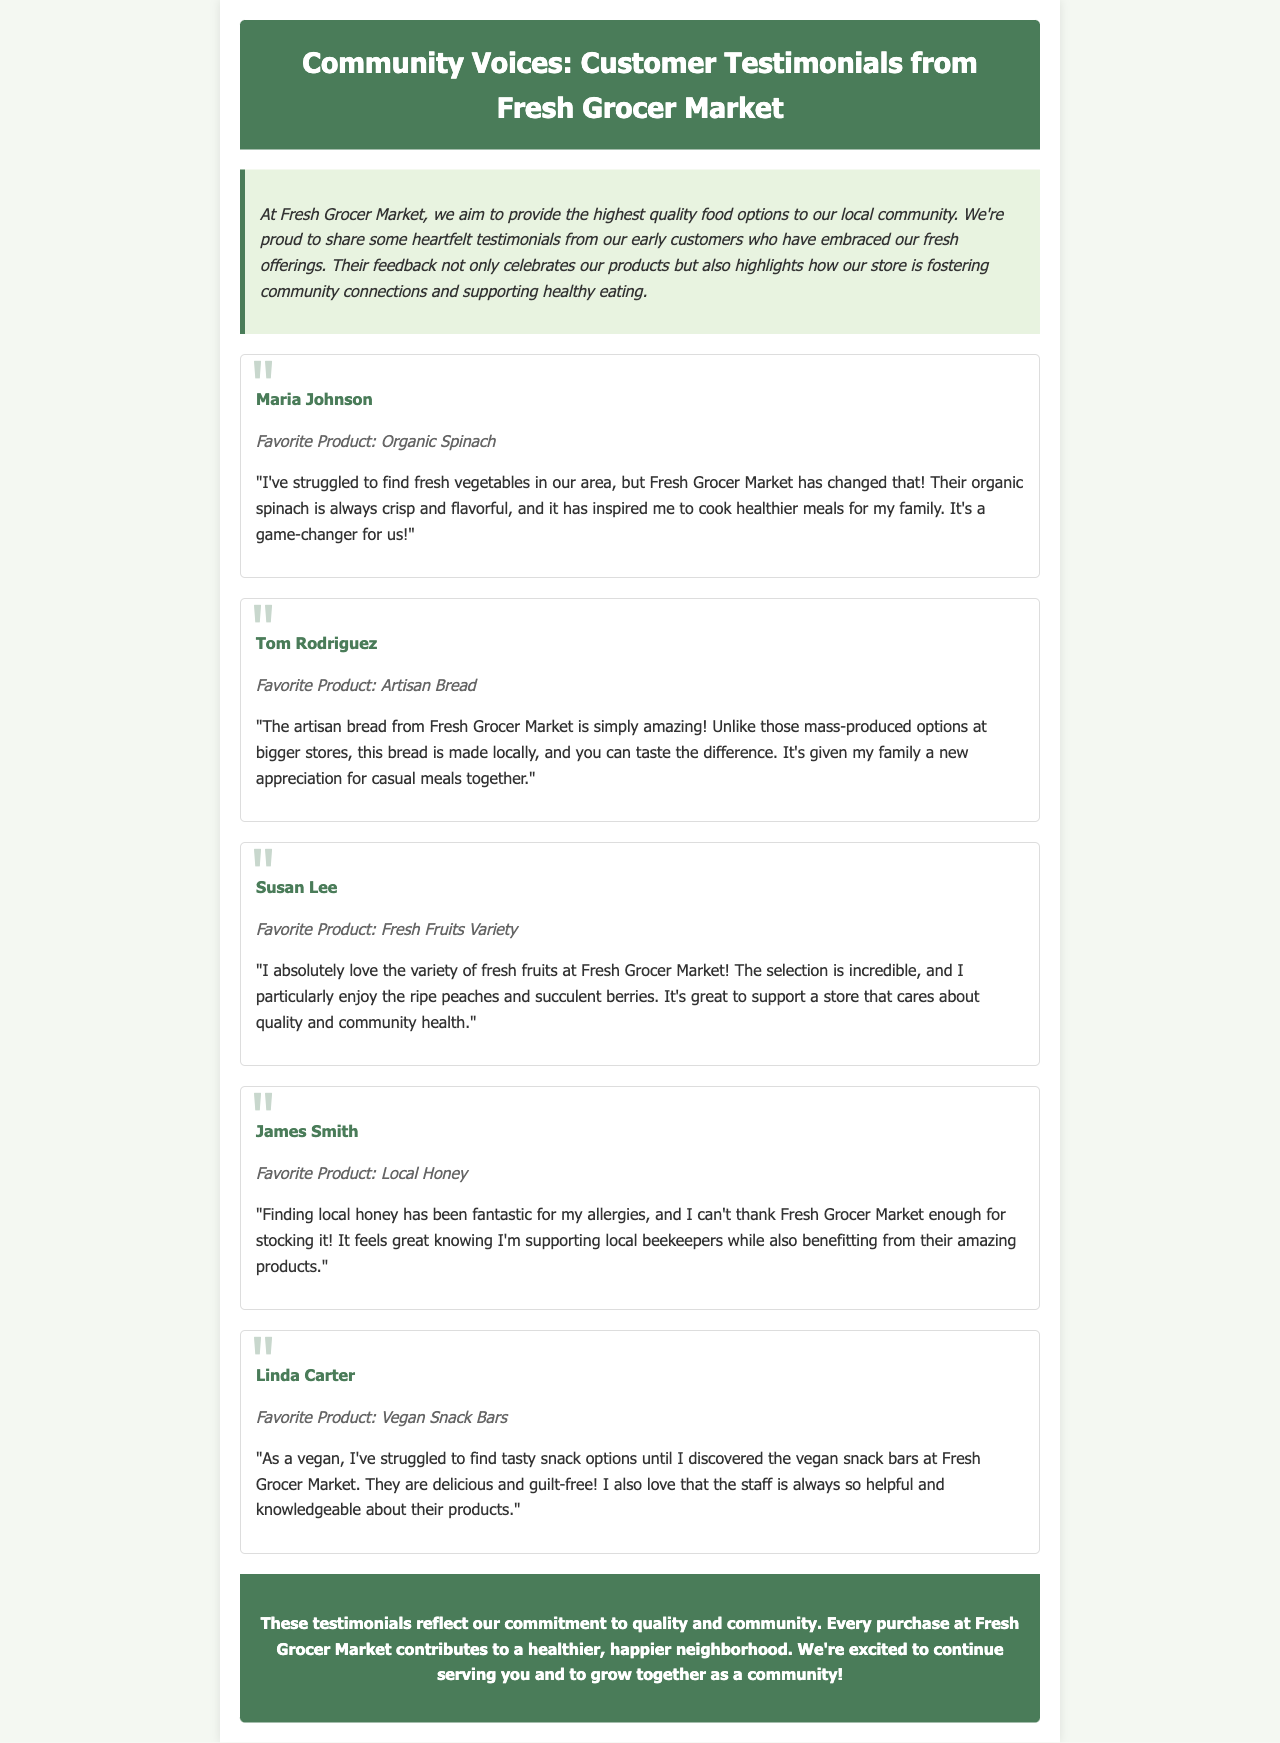What is the name of the first customer testimonial? The document presents a series of testimonials from various customers, starting with Maria Johnson.
Answer: Maria Johnson What is Maria Johnson's favorite product? According to the testimonial, Maria Johnson's favorite product is explicitly stated as organic spinach.
Answer: Organic Spinach How many testimonials are included in the newsletter? The newsletter features a total of five customer testimonials highlighting various products.
Answer: Five Which product did Tom Rodriguez appreciate most? Tom Rodriguez expresses his appreciation for artisan bread that he finds amazing compared to other options.
Answer: Artisan Bread What positive change did Fresh Grocer Market bring to Maria Johnson's cooking habits? Maria mentions that the availability of fresh vegetables has inspired her to cook healthier meals for her family.
Answer: Healthier meals What is the community impact emphasized in the conclusion of the newsletter? The concluding statement summarizes that every purchase contributes to a healthier, happier neighborhood, emphasizing community impact.
Answer: Healthier, happier neighborhood What type of store is Fresh Grocer Market categorized as? Based on the content, Fresh Grocer Market is identified as a grocery store providing fresh food options.
Answer: Grocery store Which product helps James Smith with his allergies? According to his testimonial, James Smith mentions local honey as beneficial for his allergies.
Answer: Local Honey What is Linda Carter's dietary preference? Linda identifies herself as a vegan who struggled to find tasty snack options before finding the vegan snack bars at the store.
Answer: Vegan 